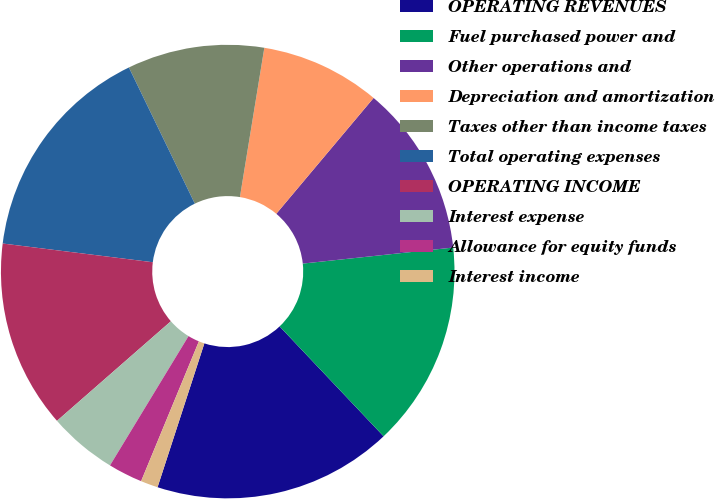Convert chart. <chart><loc_0><loc_0><loc_500><loc_500><pie_chart><fcel>OPERATING REVENUES<fcel>Fuel purchased power and<fcel>Other operations and<fcel>Depreciation and amortization<fcel>Taxes other than income taxes<fcel>Total operating expenses<fcel>OPERATING INCOME<fcel>Interest expense<fcel>Allowance for equity funds<fcel>Interest income<nl><fcel>17.07%<fcel>14.63%<fcel>12.19%<fcel>8.54%<fcel>9.76%<fcel>15.85%<fcel>13.41%<fcel>4.88%<fcel>2.45%<fcel>1.23%<nl></chart> 